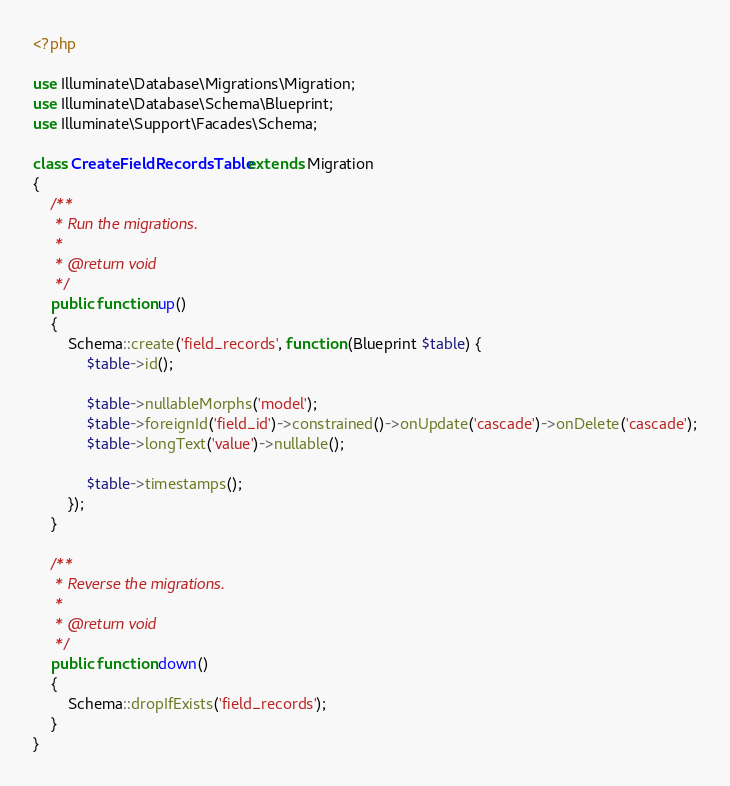Convert code to text. <code><loc_0><loc_0><loc_500><loc_500><_PHP_><?php

use Illuminate\Database\Migrations\Migration;
use Illuminate\Database\Schema\Blueprint;
use Illuminate\Support\Facades\Schema;

class CreateFieldRecordsTable extends Migration
{
    /**
     * Run the migrations.
     *
     * @return void
     */
    public function up()
    {
        Schema::create('field_records', function (Blueprint $table) {
            $table->id();

            $table->nullableMorphs('model');
            $table->foreignId('field_id')->constrained()->onUpdate('cascade')->onDelete('cascade');
            $table->longText('value')->nullable();

            $table->timestamps();
        });
    }

    /**
     * Reverse the migrations.
     *
     * @return void
     */
    public function down()
    {
        Schema::dropIfExists('field_records');
    }
}
</code> 